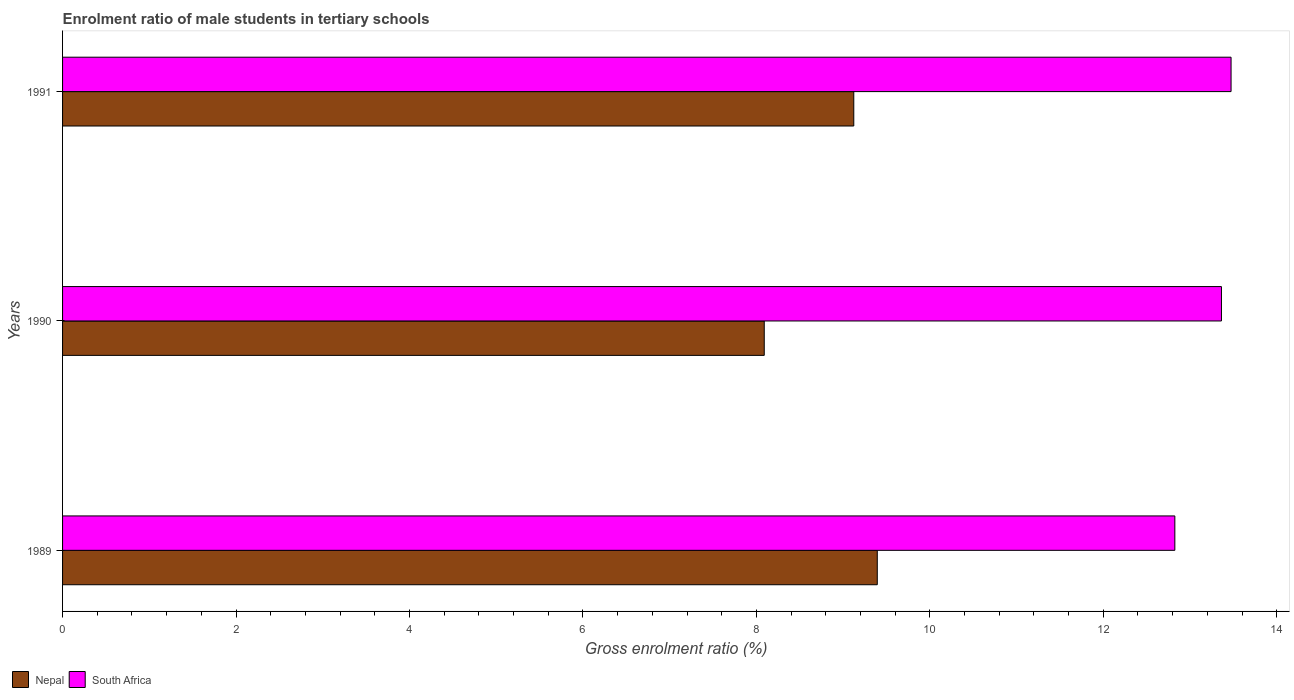Are the number of bars on each tick of the Y-axis equal?
Provide a short and direct response. Yes. How many bars are there on the 1st tick from the bottom?
Make the answer very short. 2. What is the enrolment ratio of male students in tertiary schools in Nepal in 1991?
Offer a very short reply. 9.12. Across all years, what is the maximum enrolment ratio of male students in tertiary schools in Nepal?
Your answer should be very brief. 9.39. Across all years, what is the minimum enrolment ratio of male students in tertiary schools in Nepal?
Your answer should be very brief. 8.09. In which year was the enrolment ratio of male students in tertiary schools in South Africa maximum?
Your answer should be compact. 1991. What is the total enrolment ratio of male students in tertiary schools in South Africa in the graph?
Provide a succinct answer. 39.66. What is the difference between the enrolment ratio of male students in tertiary schools in South Africa in 1989 and that in 1991?
Offer a very short reply. -0.65. What is the difference between the enrolment ratio of male students in tertiary schools in South Africa in 1990 and the enrolment ratio of male students in tertiary schools in Nepal in 1991?
Your answer should be very brief. 4.24. What is the average enrolment ratio of male students in tertiary schools in Nepal per year?
Your response must be concise. 8.87. In the year 1989, what is the difference between the enrolment ratio of male students in tertiary schools in Nepal and enrolment ratio of male students in tertiary schools in South Africa?
Provide a short and direct response. -3.43. What is the ratio of the enrolment ratio of male students in tertiary schools in Nepal in 1990 to that in 1991?
Keep it short and to the point. 0.89. Is the difference between the enrolment ratio of male students in tertiary schools in Nepal in 1990 and 1991 greater than the difference between the enrolment ratio of male students in tertiary schools in South Africa in 1990 and 1991?
Make the answer very short. No. What is the difference between the highest and the second highest enrolment ratio of male students in tertiary schools in South Africa?
Keep it short and to the point. 0.11. What is the difference between the highest and the lowest enrolment ratio of male students in tertiary schools in Nepal?
Offer a terse response. 1.3. In how many years, is the enrolment ratio of male students in tertiary schools in South Africa greater than the average enrolment ratio of male students in tertiary schools in South Africa taken over all years?
Make the answer very short. 2. What does the 1st bar from the top in 1990 represents?
Give a very brief answer. South Africa. What does the 1st bar from the bottom in 1990 represents?
Provide a short and direct response. Nepal. Are all the bars in the graph horizontal?
Ensure brevity in your answer.  Yes. Are the values on the major ticks of X-axis written in scientific E-notation?
Give a very brief answer. No. Does the graph contain any zero values?
Keep it short and to the point. No. Does the graph contain grids?
Offer a very short reply. No. Where does the legend appear in the graph?
Keep it short and to the point. Bottom left. How are the legend labels stacked?
Make the answer very short. Horizontal. What is the title of the graph?
Provide a succinct answer. Enrolment ratio of male students in tertiary schools. What is the label or title of the X-axis?
Your answer should be compact. Gross enrolment ratio (%). What is the label or title of the Y-axis?
Provide a succinct answer. Years. What is the Gross enrolment ratio (%) in Nepal in 1989?
Give a very brief answer. 9.39. What is the Gross enrolment ratio (%) of South Africa in 1989?
Offer a very short reply. 12.83. What is the Gross enrolment ratio (%) of Nepal in 1990?
Ensure brevity in your answer.  8.09. What is the Gross enrolment ratio (%) of South Africa in 1990?
Your answer should be very brief. 13.36. What is the Gross enrolment ratio (%) of Nepal in 1991?
Make the answer very short. 9.12. What is the Gross enrolment ratio (%) in South Africa in 1991?
Provide a short and direct response. 13.47. Across all years, what is the maximum Gross enrolment ratio (%) of Nepal?
Your answer should be compact. 9.39. Across all years, what is the maximum Gross enrolment ratio (%) of South Africa?
Make the answer very short. 13.47. Across all years, what is the minimum Gross enrolment ratio (%) in Nepal?
Ensure brevity in your answer.  8.09. Across all years, what is the minimum Gross enrolment ratio (%) in South Africa?
Make the answer very short. 12.83. What is the total Gross enrolment ratio (%) of Nepal in the graph?
Make the answer very short. 26.61. What is the total Gross enrolment ratio (%) in South Africa in the graph?
Make the answer very short. 39.66. What is the difference between the Gross enrolment ratio (%) in Nepal in 1989 and that in 1990?
Your answer should be compact. 1.3. What is the difference between the Gross enrolment ratio (%) of South Africa in 1989 and that in 1990?
Ensure brevity in your answer.  -0.54. What is the difference between the Gross enrolment ratio (%) of Nepal in 1989 and that in 1991?
Keep it short and to the point. 0.27. What is the difference between the Gross enrolment ratio (%) in South Africa in 1989 and that in 1991?
Your answer should be very brief. -0.65. What is the difference between the Gross enrolment ratio (%) of Nepal in 1990 and that in 1991?
Offer a very short reply. -1.03. What is the difference between the Gross enrolment ratio (%) of South Africa in 1990 and that in 1991?
Give a very brief answer. -0.11. What is the difference between the Gross enrolment ratio (%) of Nepal in 1989 and the Gross enrolment ratio (%) of South Africa in 1990?
Your response must be concise. -3.97. What is the difference between the Gross enrolment ratio (%) in Nepal in 1989 and the Gross enrolment ratio (%) in South Africa in 1991?
Your answer should be compact. -4.08. What is the difference between the Gross enrolment ratio (%) of Nepal in 1990 and the Gross enrolment ratio (%) of South Africa in 1991?
Provide a short and direct response. -5.38. What is the average Gross enrolment ratio (%) in Nepal per year?
Make the answer very short. 8.87. What is the average Gross enrolment ratio (%) in South Africa per year?
Keep it short and to the point. 13.22. In the year 1989, what is the difference between the Gross enrolment ratio (%) in Nepal and Gross enrolment ratio (%) in South Africa?
Keep it short and to the point. -3.43. In the year 1990, what is the difference between the Gross enrolment ratio (%) in Nepal and Gross enrolment ratio (%) in South Africa?
Your answer should be compact. -5.27. In the year 1991, what is the difference between the Gross enrolment ratio (%) in Nepal and Gross enrolment ratio (%) in South Africa?
Provide a short and direct response. -4.35. What is the ratio of the Gross enrolment ratio (%) in Nepal in 1989 to that in 1990?
Your answer should be compact. 1.16. What is the ratio of the Gross enrolment ratio (%) in South Africa in 1989 to that in 1990?
Provide a succinct answer. 0.96. What is the ratio of the Gross enrolment ratio (%) in Nepal in 1989 to that in 1991?
Your answer should be compact. 1.03. What is the ratio of the Gross enrolment ratio (%) of South Africa in 1989 to that in 1991?
Offer a very short reply. 0.95. What is the ratio of the Gross enrolment ratio (%) of Nepal in 1990 to that in 1991?
Provide a succinct answer. 0.89. What is the ratio of the Gross enrolment ratio (%) of South Africa in 1990 to that in 1991?
Keep it short and to the point. 0.99. What is the difference between the highest and the second highest Gross enrolment ratio (%) of Nepal?
Your answer should be very brief. 0.27. What is the difference between the highest and the second highest Gross enrolment ratio (%) of South Africa?
Ensure brevity in your answer.  0.11. What is the difference between the highest and the lowest Gross enrolment ratio (%) in Nepal?
Your answer should be compact. 1.3. What is the difference between the highest and the lowest Gross enrolment ratio (%) of South Africa?
Offer a very short reply. 0.65. 